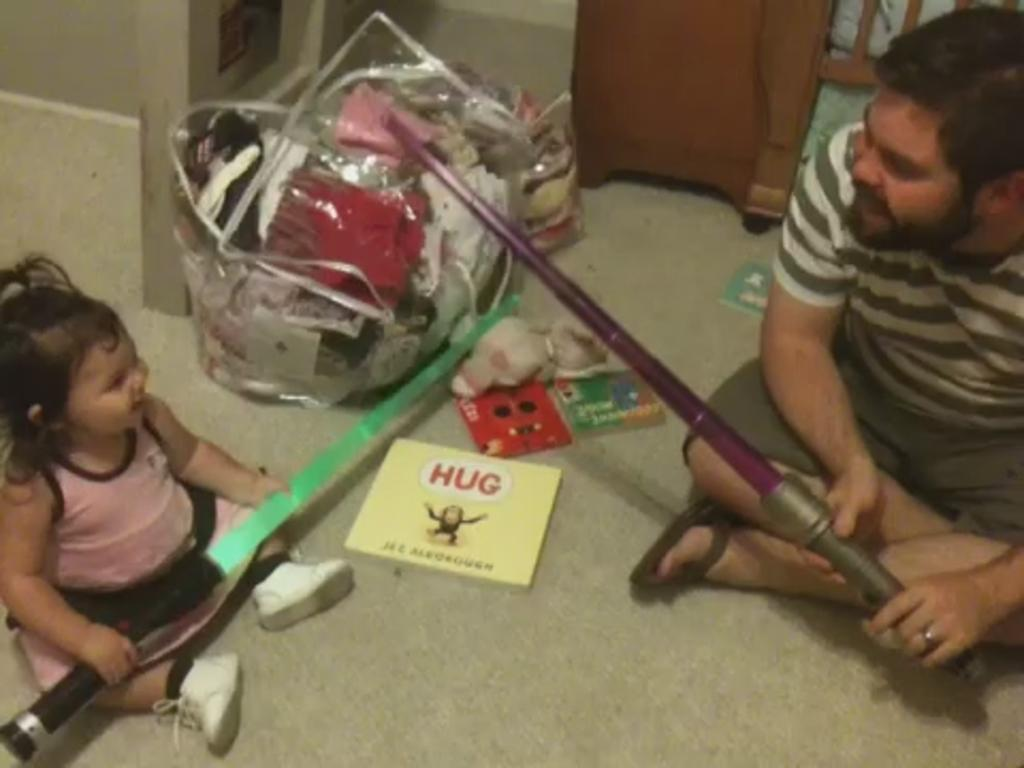Who is present in the image? There is a man and a kid in the image. What are the man and the kid doing in the image? The man and the kid are holding an object in the image. What else can be seen in the image besides the man and the kid? There is baggage, books, and a toy visible in the image. How many goldfish are swimming in the toy in the image? There are no goldfish present in the image, and the toy does not contain any water for fish to swim in. 